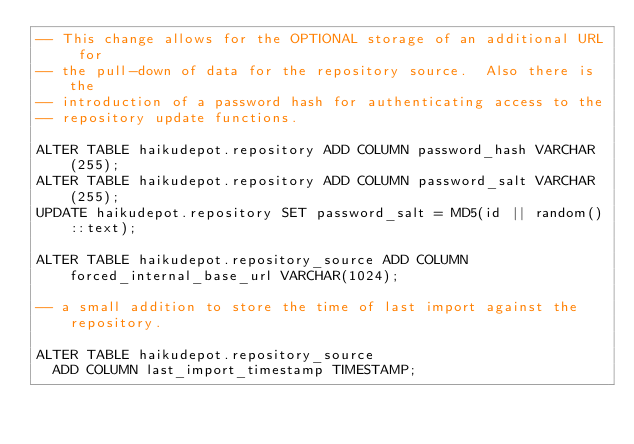<code> <loc_0><loc_0><loc_500><loc_500><_SQL_>-- This change allows for the OPTIONAL storage of an additional URL for
-- the pull-down of data for the repository source.  Also there is the
-- introduction of a password hash for authenticating access to the
-- repository update functions.

ALTER TABLE haikudepot.repository ADD COLUMN password_hash VARCHAR(255);
ALTER TABLE haikudepot.repository ADD COLUMN password_salt VARCHAR(255);
UPDATE haikudepot.repository SET password_salt = MD5(id || random()::text);

ALTER TABLE haikudepot.repository_source ADD COLUMN forced_internal_base_url VARCHAR(1024);

-- a small addition to store the time of last import against the repository.

ALTER TABLE haikudepot.repository_source
  ADD COLUMN last_import_timestamp TIMESTAMP;</code> 